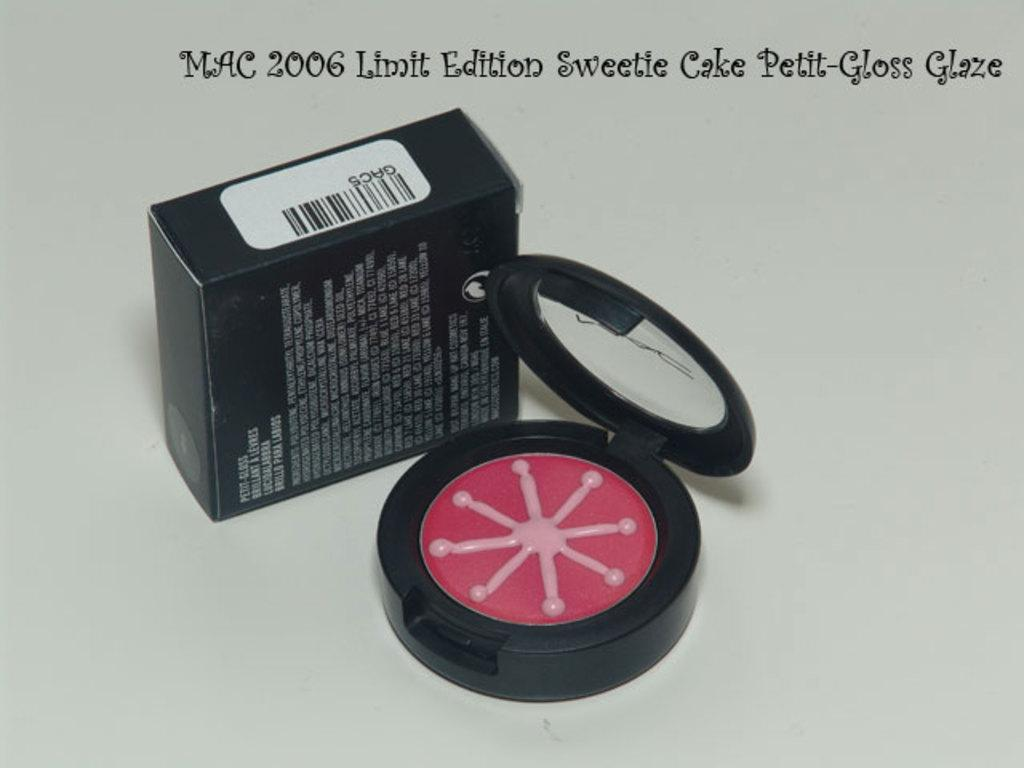Provide a one-sentence caption for the provided image. A sweetie cake petit-gloss glaze for women colored red. 